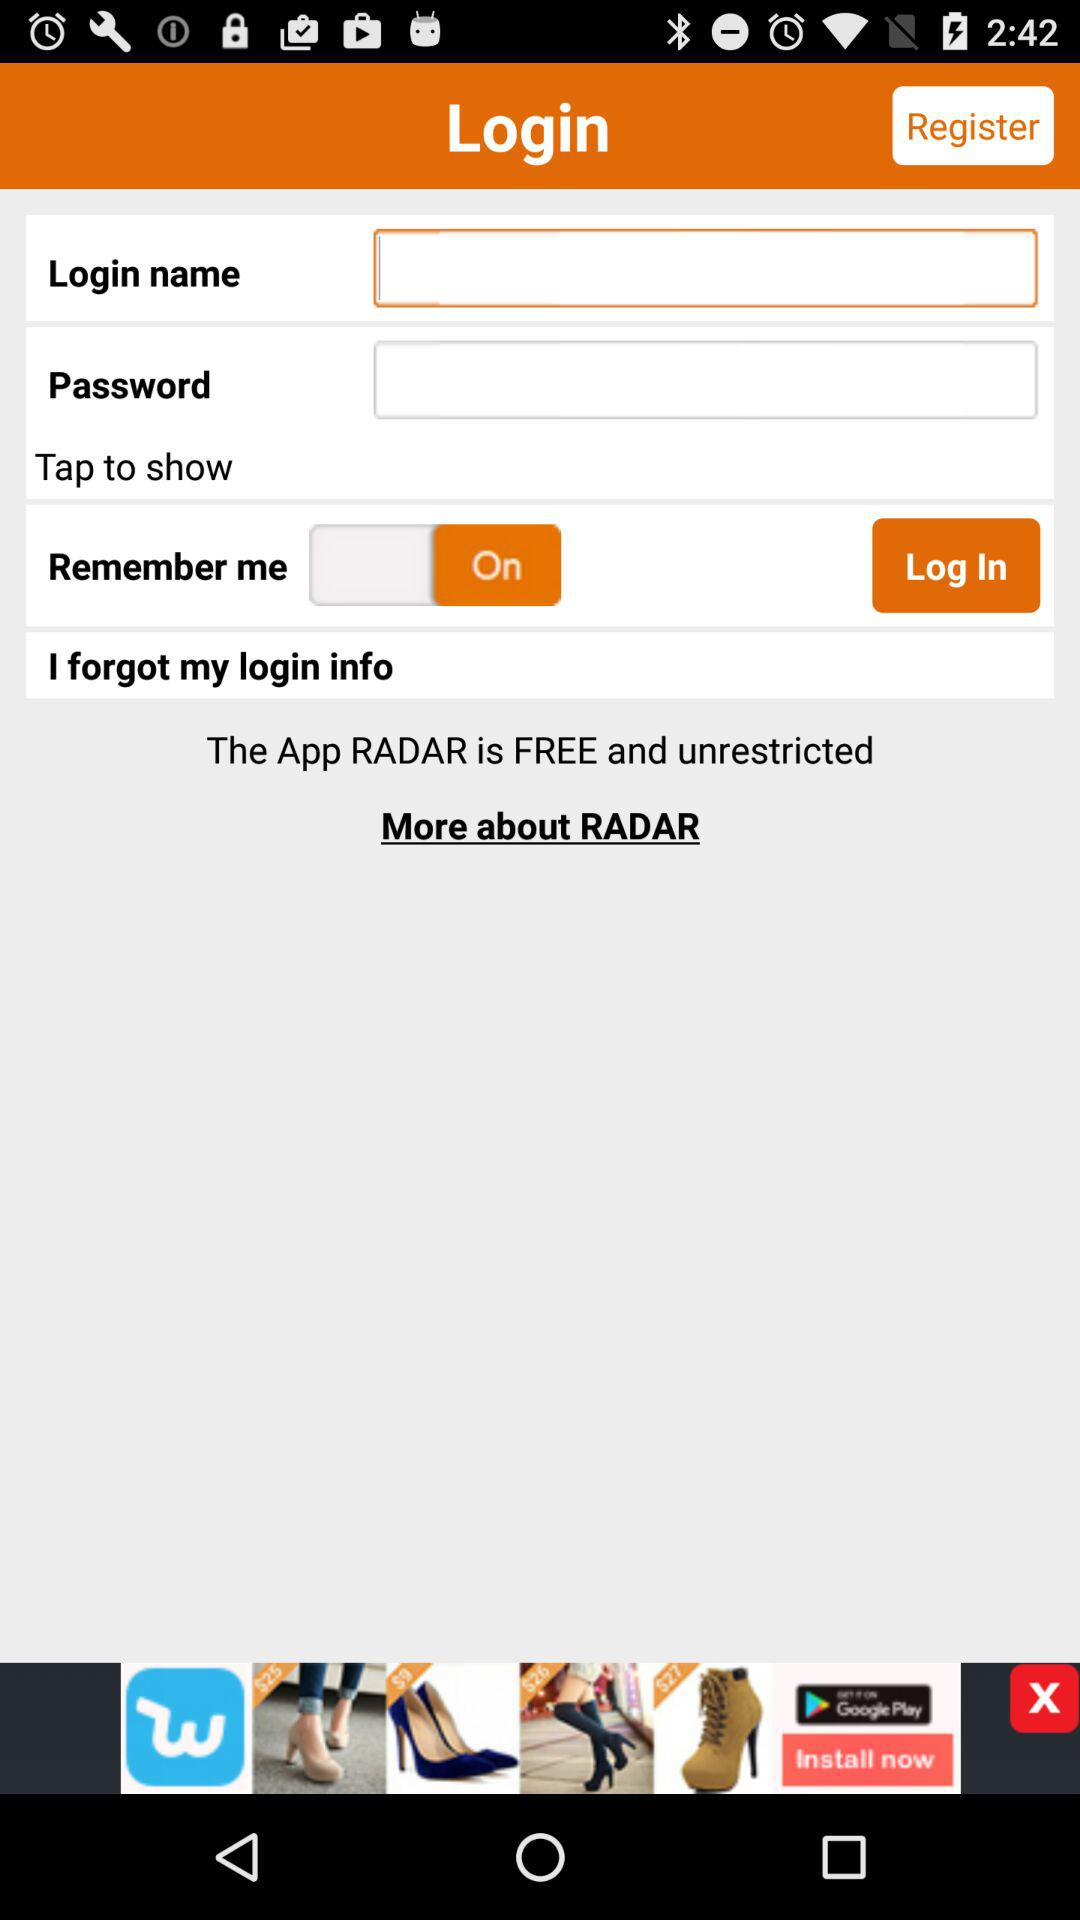What are the requirements to get a login?
When the provided information is insufficient, respond with <no answer>. <no answer> 